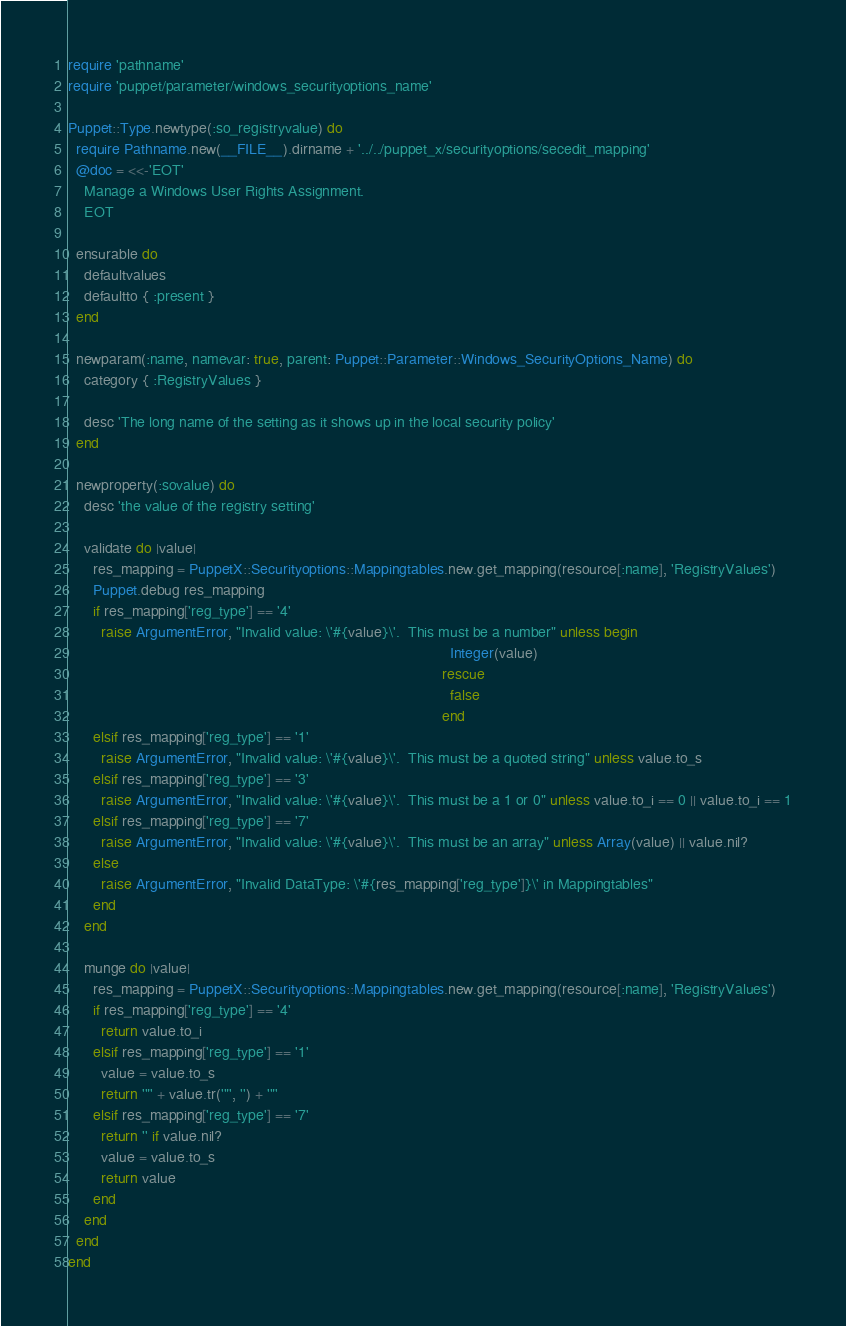<code> <loc_0><loc_0><loc_500><loc_500><_Ruby_>require 'pathname'
require 'puppet/parameter/windows_securityoptions_name'

Puppet::Type.newtype(:so_registryvalue) do
  require Pathname.new(__FILE__).dirname + '../../puppet_x/securityoptions/secedit_mapping'
  @doc = <<-'EOT'
    Manage a Windows User Rights Assignment.
    EOT

  ensurable do
    defaultvalues
    defaultto { :present }
  end

  newparam(:name, namevar: true, parent: Puppet::Parameter::Windows_SecurityOptions_Name) do
    category { :RegistryValues }

    desc 'The long name of the setting as it shows up in the local security policy'
  end

  newproperty(:sovalue) do
    desc 'the value of the registry setting'

    validate do |value|
      res_mapping = PuppetX::Securityoptions::Mappingtables.new.get_mapping(resource[:name], 'RegistryValues')
      Puppet.debug res_mapping
      if res_mapping['reg_type'] == '4'
        raise ArgumentError, "Invalid value: \'#{value}\'.  This must be a number" unless begin
                                                                                             Integer(value)
                                                                                           rescue
                                                                                             false
                                                                                           end
      elsif res_mapping['reg_type'] == '1'
        raise ArgumentError, "Invalid value: \'#{value}\'.  This must be a quoted string" unless value.to_s
      elsif res_mapping['reg_type'] == '3'
        raise ArgumentError, "Invalid value: \'#{value}\'.  This must be a 1 or 0" unless value.to_i == 0 || value.to_i == 1
      elsif res_mapping['reg_type'] == '7'
        raise ArgumentError, "Invalid value: \'#{value}\'.  This must be an array" unless Array(value) || value.nil?
      else
        raise ArgumentError, "Invalid DataType: \'#{res_mapping['reg_type']}\' in Mappingtables"
      end
    end

    munge do |value|
      res_mapping = PuppetX::Securityoptions::Mappingtables.new.get_mapping(resource[:name], 'RegistryValues')
      if res_mapping['reg_type'] == '4'
        return value.to_i
      elsif res_mapping['reg_type'] == '1'
        value = value.to_s
        return '"' + value.tr('"', '') + '"'
      elsif res_mapping['reg_type'] == '7'
        return '' if value.nil?
        value = value.to_s
        return value
      end
    end
  end
end
</code> 